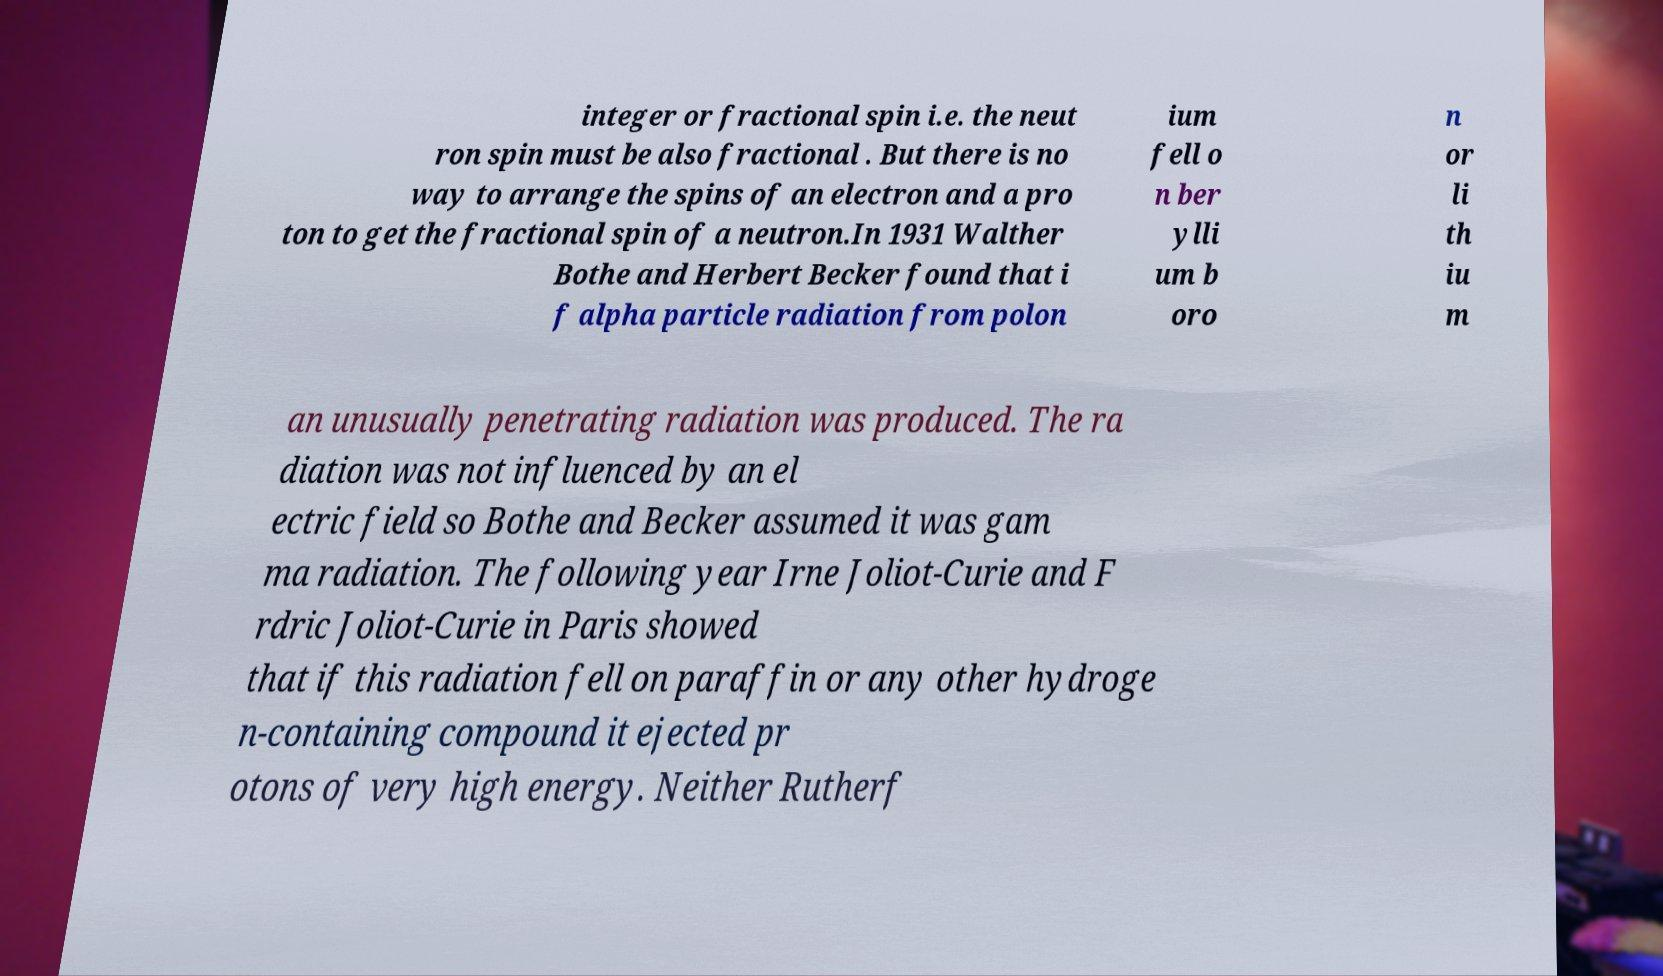I need the written content from this picture converted into text. Can you do that? integer or fractional spin i.e. the neut ron spin must be also fractional . But there is no way to arrange the spins of an electron and a pro ton to get the fractional spin of a neutron.In 1931 Walther Bothe and Herbert Becker found that i f alpha particle radiation from polon ium fell o n ber ylli um b oro n or li th iu m an unusually penetrating radiation was produced. The ra diation was not influenced by an el ectric field so Bothe and Becker assumed it was gam ma radiation. The following year Irne Joliot-Curie and F rdric Joliot-Curie in Paris showed that if this radiation fell on paraffin or any other hydroge n-containing compound it ejected pr otons of very high energy. Neither Rutherf 